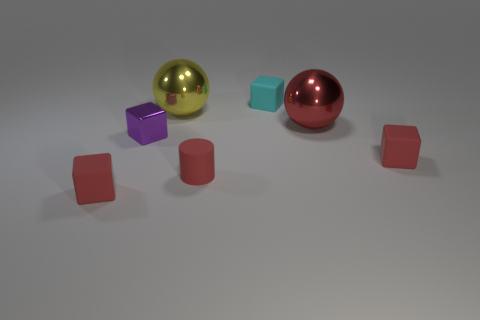How many other objects are there of the same color as the tiny matte cylinder?
Offer a very short reply. 3. Is the number of purple things behind the small cyan thing less than the number of tiny red rubber things left of the small matte cylinder?
Give a very brief answer. Yes. How many things are either large things that are on the right side of the tiny cyan matte thing or gray matte spheres?
Provide a succinct answer. 1. There is a red cylinder; is it the same size as the rubber object that is on the left side of the large yellow sphere?
Provide a short and direct response. Yes. There is a red object that is the same shape as the big yellow metallic thing; what size is it?
Provide a short and direct response. Large. There is a matte cube in front of the matte cube that is to the right of the tiny cyan rubber cube; how many matte blocks are behind it?
Offer a terse response. 2. What number of cylinders are large gray rubber things or small purple metallic objects?
Give a very brief answer. 0. What is the color of the rubber cube that is behind the tiny red rubber cube right of the red matte block to the left of the purple cube?
Provide a succinct answer. Cyan. How many other things are the same size as the cyan object?
Provide a short and direct response. 4. There is another large shiny thing that is the same shape as the yellow object; what color is it?
Offer a very short reply. Red. 